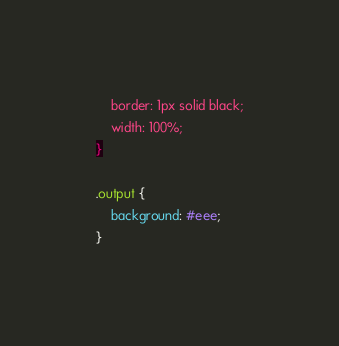Convert code to text. <code><loc_0><loc_0><loc_500><loc_500><_CSS_>    border: 1px solid black;
    width: 100%;
}

.output {
    background: #eee;
}
</code> 